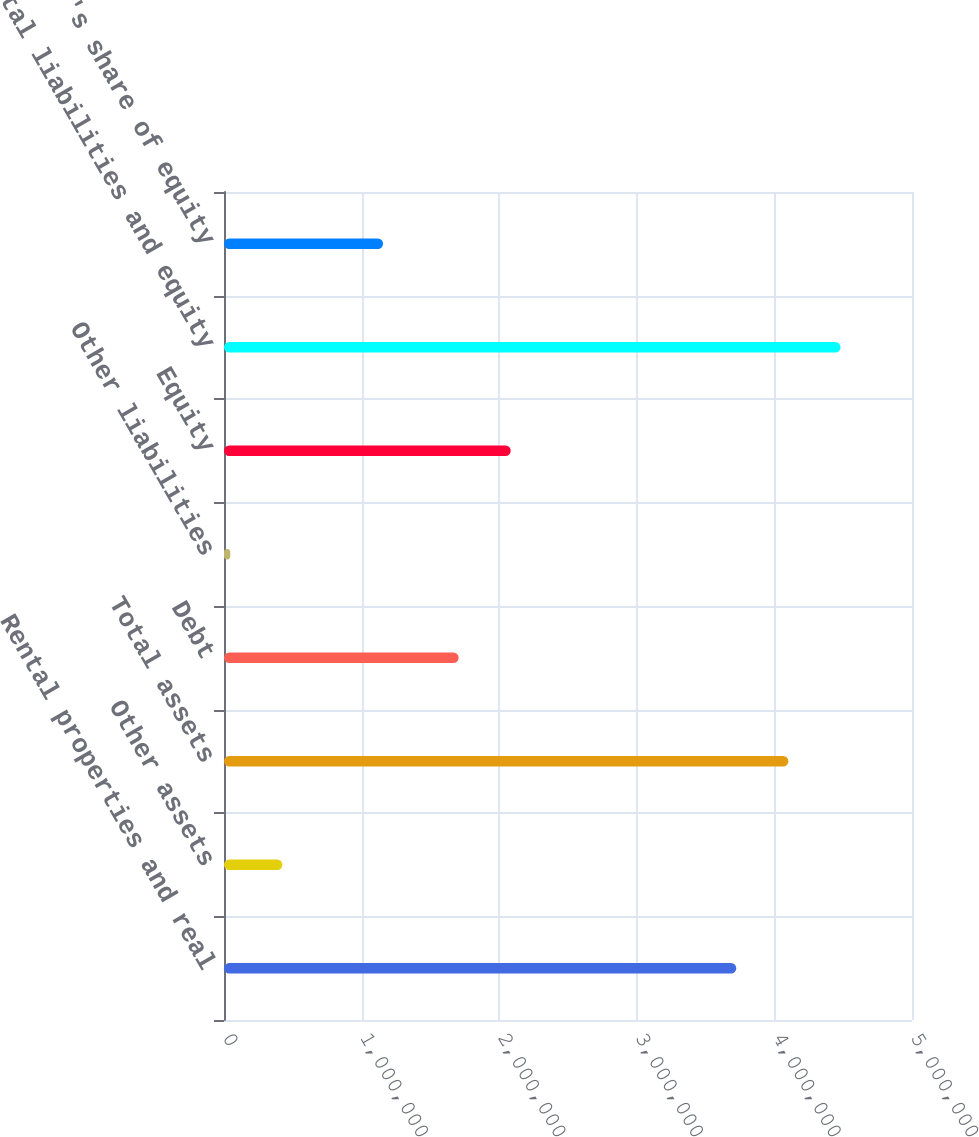Convert chart. <chart><loc_0><loc_0><loc_500><loc_500><bar_chart><fcel>Rental properties and real<fcel>Other assets<fcel>Total assets<fcel>Debt<fcel>Other liabilities<fcel>Equity<fcel>Total liabilities and equity<fcel>Company's share of equity<nl><fcel>3.72278e+06<fcel>424275<fcel>4.10154e+06<fcel>1.70505e+06<fcel>45515<fcel>2.08381e+06<fcel>4.4803e+06<fcel>1.15598e+06<nl></chart> 